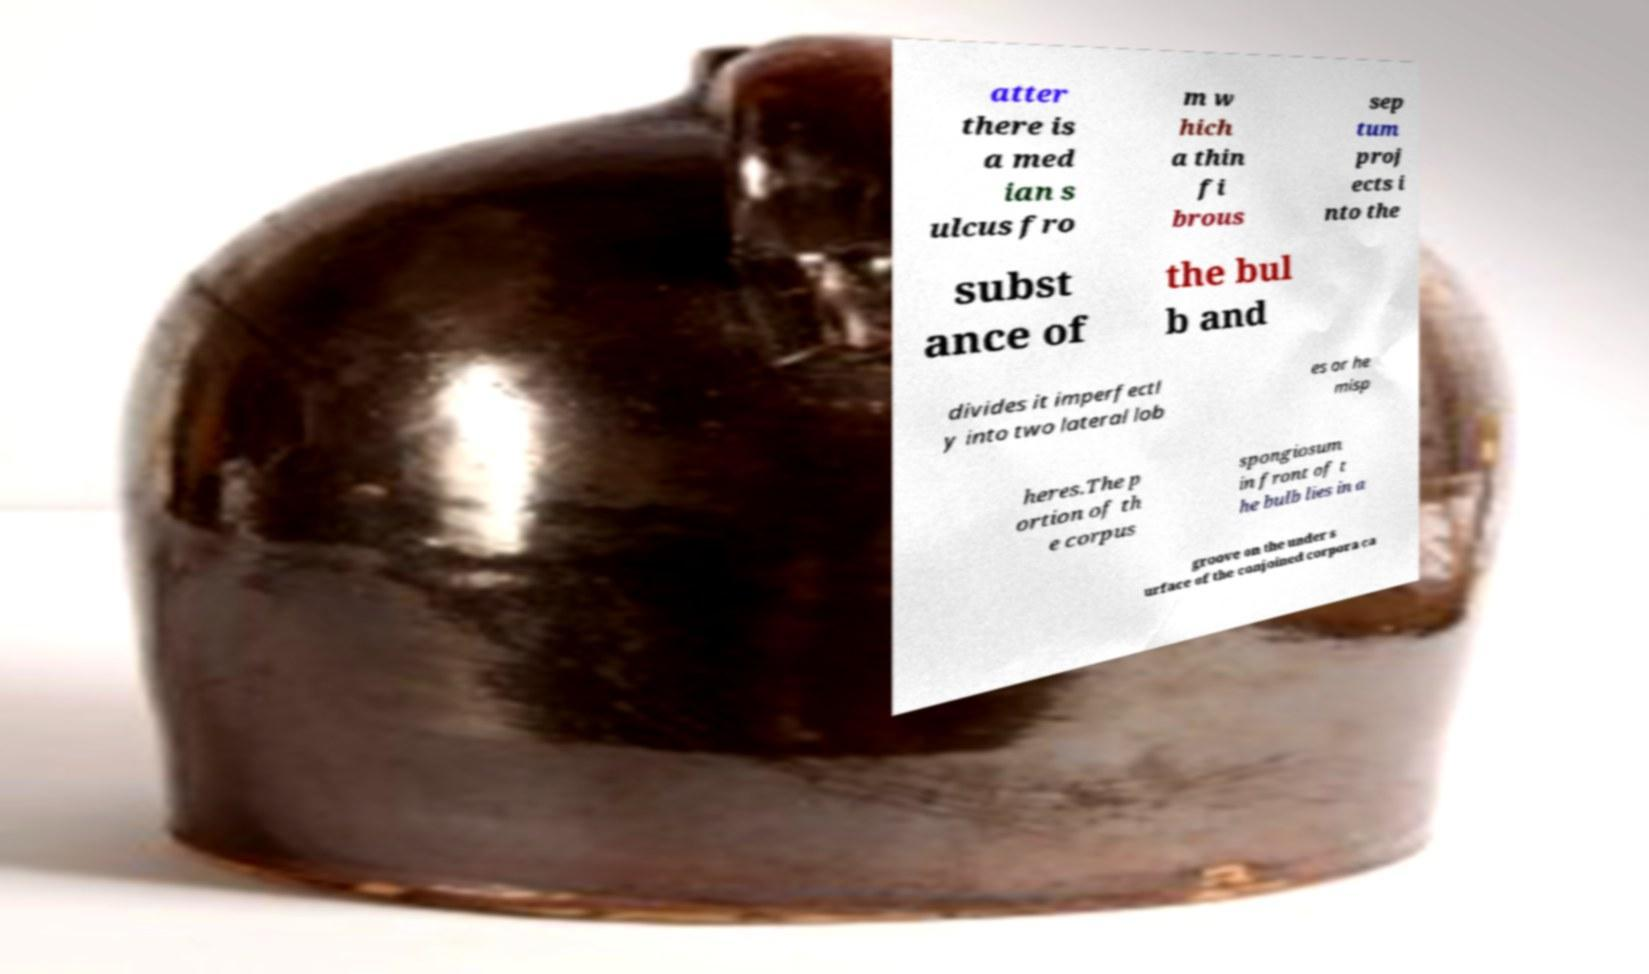Could you extract and type out the text from this image? atter there is a med ian s ulcus fro m w hich a thin fi brous sep tum proj ects i nto the subst ance of the bul b and divides it imperfectl y into two lateral lob es or he misp heres.The p ortion of th e corpus spongiosum in front of t he bulb lies in a groove on the under s urface of the conjoined corpora ca 